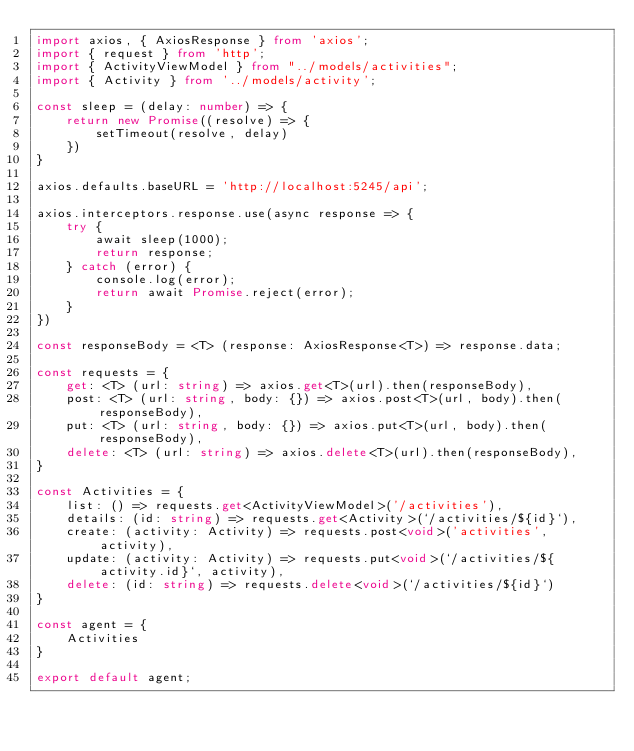Convert code to text. <code><loc_0><loc_0><loc_500><loc_500><_TypeScript_>import axios, { AxiosResponse } from 'axios';
import { request } from 'http';
import { ActivityViewModel } from "../models/activities";
import { Activity } from '../models/activity';

const sleep = (delay: number) => {
    return new Promise((resolve) => {
        setTimeout(resolve, delay)
    })
}

axios.defaults.baseURL = 'http://localhost:5245/api';

axios.interceptors.response.use(async response => {
    try {
        await sleep(1000);
        return response;
    } catch (error) {
        console.log(error);
        return await Promise.reject(error);
    }
})

const responseBody = <T> (response: AxiosResponse<T>) => response.data;

const requests = {
    get: <T> (url: string) => axios.get<T>(url).then(responseBody),
    post: <T> (url: string, body: {}) => axios.post<T>(url, body).then(responseBody),
    put: <T> (url: string, body: {}) => axios.put<T>(url, body).then(responseBody),
    delete: <T> (url: string) => axios.delete<T>(url).then(responseBody),
}

const Activities = {
    list: () => requests.get<ActivityViewModel>('/activities'),
    details: (id: string) => requests.get<Activity>(`/activities/${id}`),
    create: (activity: Activity) => requests.post<void>('activities', activity),
    update: (activity: Activity) => requests.put<void>(`/activities/${activity.id}`, activity),
    delete: (id: string) => requests.delete<void>(`/activities/${id}`)
}

const agent = {
    Activities
}

export default agent;

</code> 